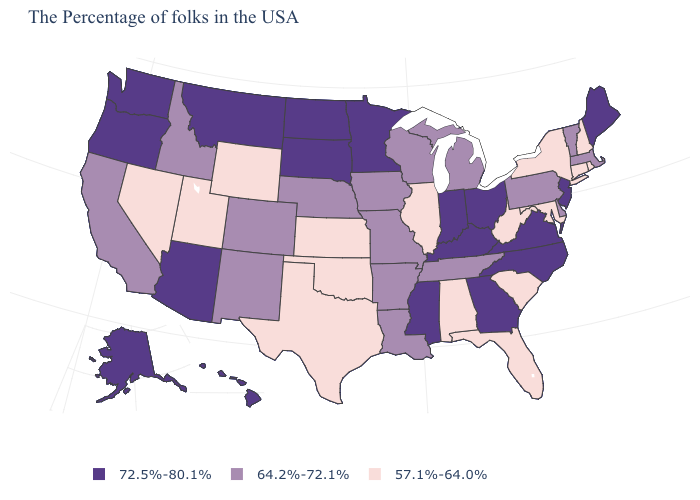Does Missouri have the same value as Florida?
Give a very brief answer. No. Name the states that have a value in the range 57.1%-64.0%?
Concise answer only. Rhode Island, New Hampshire, Connecticut, New York, Maryland, South Carolina, West Virginia, Florida, Alabama, Illinois, Kansas, Oklahoma, Texas, Wyoming, Utah, Nevada. Is the legend a continuous bar?
Write a very short answer. No. Does Indiana have the same value as Georgia?
Short answer required. Yes. Name the states that have a value in the range 64.2%-72.1%?
Write a very short answer. Massachusetts, Vermont, Delaware, Pennsylvania, Michigan, Tennessee, Wisconsin, Louisiana, Missouri, Arkansas, Iowa, Nebraska, Colorado, New Mexico, Idaho, California. Which states have the lowest value in the South?
Write a very short answer. Maryland, South Carolina, West Virginia, Florida, Alabama, Oklahoma, Texas. How many symbols are there in the legend?
Write a very short answer. 3. Does Nebraska have the highest value in the MidWest?
Be succinct. No. What is the value of West Virginia?
Give a very brief answer. 57.1%-64.0%. Is the legend a continuous bar?
Give a very brief answer. No. Among the states that border Mississippi , does Alabama have the highest value?
Answer briefly. No. Name the states that have a value in the range 72.5%-80.1%?
Concise answer only. Maine, New Jersey, Virginia, North Carolina, Ohio, Georgia, Kentucky, Indiana, Mississippi, Minnesota, South Dakota, North Dakota, Montana, Arizona, Washington, Oregon, Alaska, Hawaii. Name the states that have a value in the range 64.2%-72.1%?
Write a very short answer. Massachusetts, Vermont, Delaware, Pennsylvania, Michigan, Tennessee, Wisconsin, Louisiana, Missouri, Arkansas, Iowa, Nebraska, Colorado, New Mexico, Idaho, California. What is the lowest value in the MidWest?
Concise answer only. 57.1%-64.0%. Among the states that border Pennsylvania , does Maryland have the lowest value?
Be succinct. Yes. 